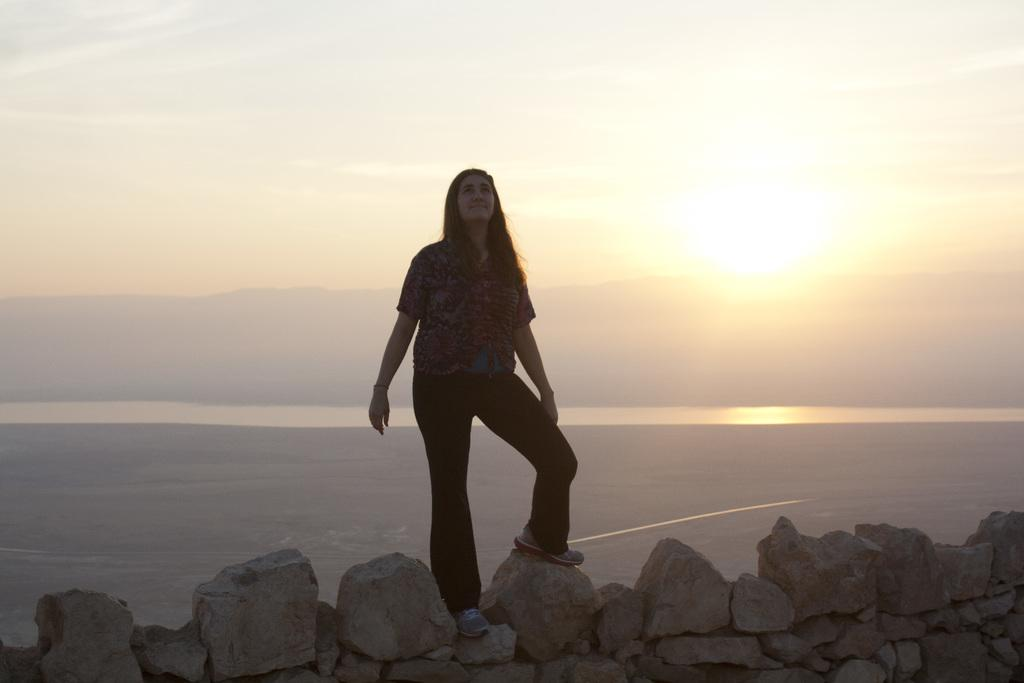What is the woman doing in the image? The woman is standing on a rock in the image. What can be seen below the woman in the image? There is water visible in the image. What is visible in the background of the image? There are mountains in the background of the image. What is visible in the sky in the image? The sky is visible in the image, and there are clouds and the sun visible. Can you see any snails crawling on the woman's shoes in the image? There are no snails visible in the image. 